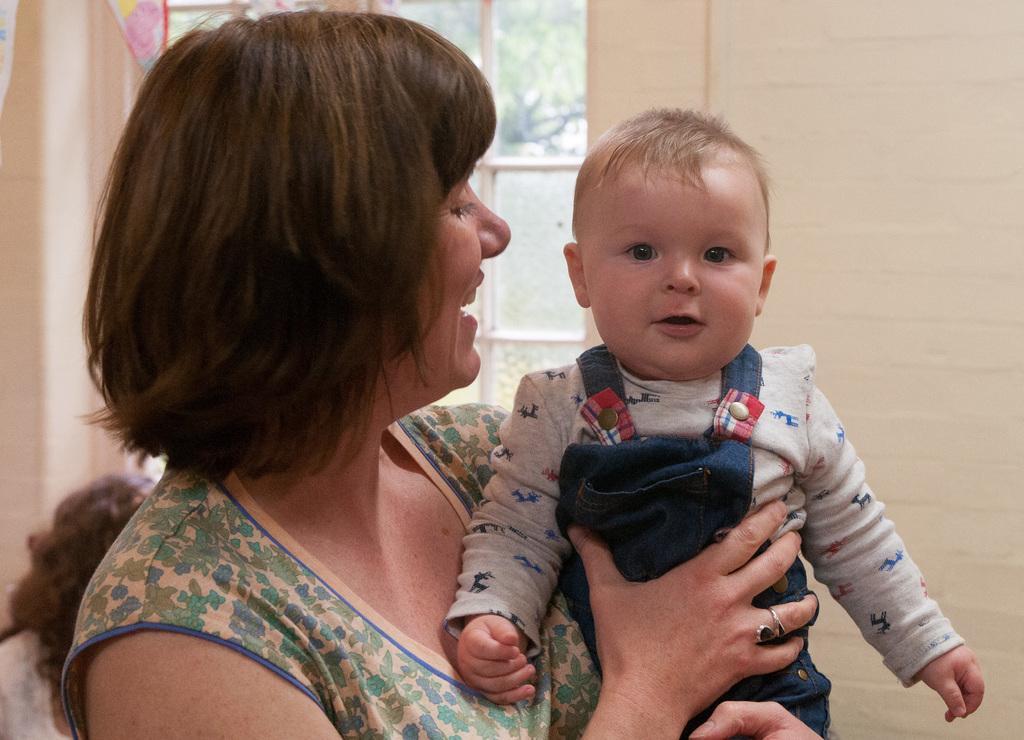In one or two sentences, can you explain what this image depicts? In the picture I can see a woman wearing a dress is standing here and carrying a child. The background of the image is slightly blurred, where we can see another person, the wall and I can see glass windows through which I can see trees. 